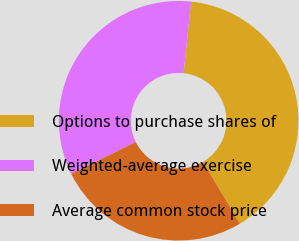Convert chart to OTSL. <chart><loc_0><loc_0><loc_500><loc_500><pie_chart><fcel>Options to purchase shares of<fcel>Weighted-average exercise<fcel>Average common stock price<nl><fcel>39.81%<fcel>33.98%<fcel>26.21%<nl></chart> 